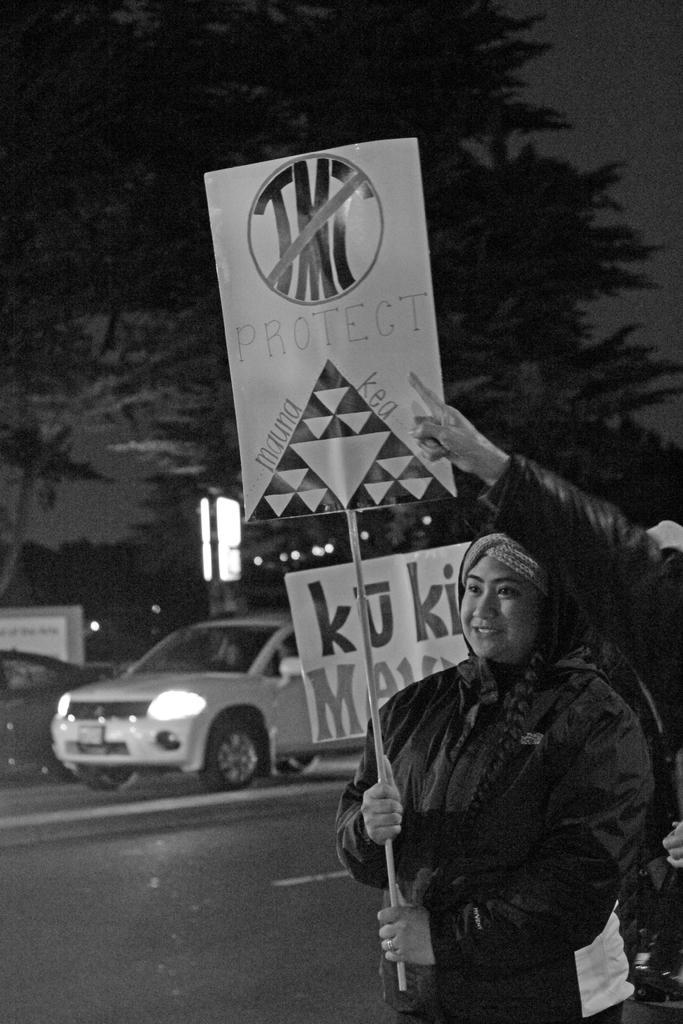Please provide a concise description of this image. This is a black and white image. There are a few people and vehicles. We can see the ground. There are a few boards with text and images. We can also see some trees and a light. We can see the sky and an object on the left. 